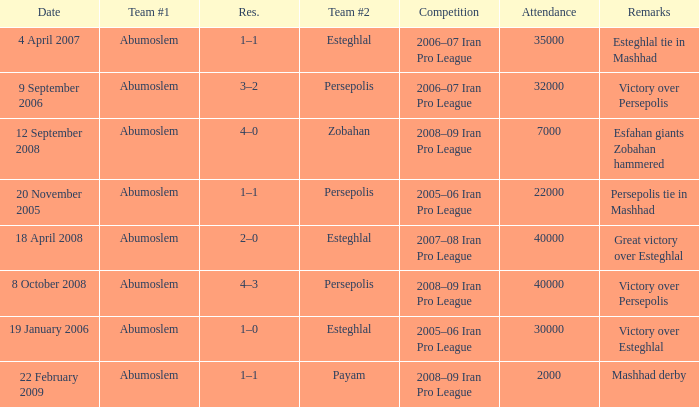What was the res for the game against Payam? 1–1. 